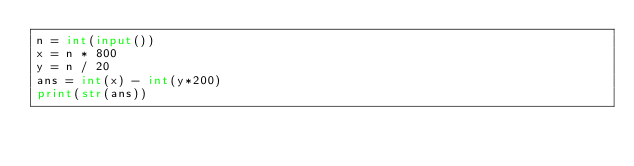Convert code to text. <code><loc_0><loc_0><loc_500><loc_500><_Python_>n = int(input())
x = n * 800
y = n / 20
ans = int(x) - int(y*200)
print(str(ans))</code> 